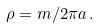<formula> <loc_0><loc_0><loc_500><loc_500>\rho = m / 2 \pi a \, .</formula> 